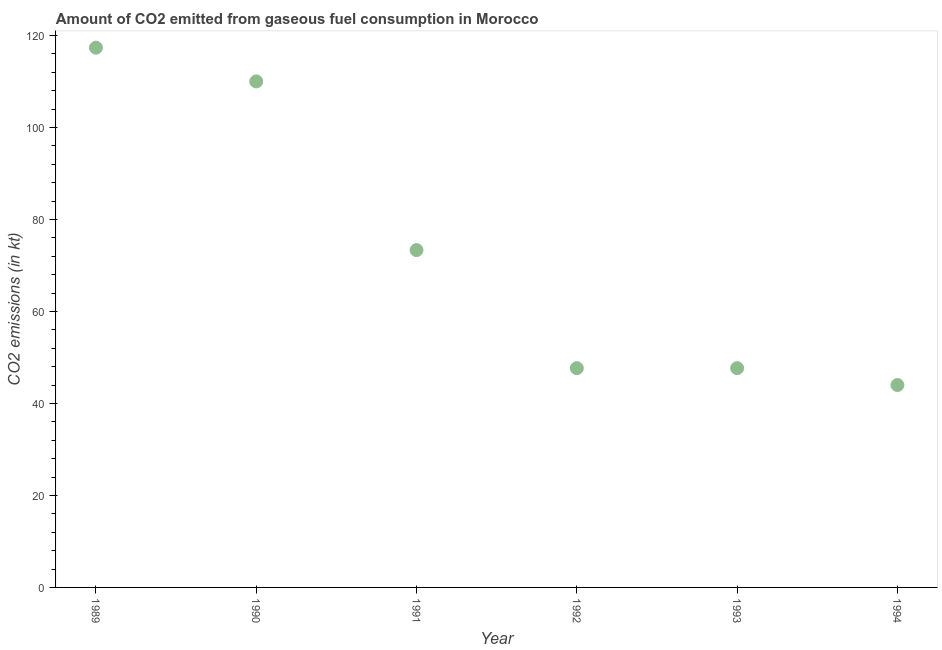What is the co2 emissions from gaseous fuel consumption in 1992?
Ensure brevity in your answer.  47.67. Across all years, what is the maximum co2 emissions from gaseous fuel consumption?
Provide a short and direct response. 117.34. Across all years, what is the minimum co2 emissions from gaseous fuel consumption?
Keep it short and to the point. 44. What is the sum of the co2 emissions from gaseous fuel consumption?
Your answer should be very brief. 440.04. What is the difference between the co2 emissions from gaseous fuel consumption in 1990 and 1994?
Provide a short and direct response. 66.01. What is the average co2 emissions from gaseous fuel consumption per year?
Your answer should be compact. 73.34. What is the median co2 emissions from gaseous fuel consumption?
Make the answer very short. 60.51. In how many years, is the co2 emissions from gaseous fuel consumption greater than 80 kt?
Your answer should be very brief. 2. What is the ratio of the co2 emissions from gaseous fuel consumption in 1989 to that in 1993?
Offer a very short reply. 2.46. What is the difference between the highest and the second highest co2 emissions from gaseous fuel consumption?
Make the answer very short. 7.33. Is the sum of the co2 emissions from gaseous fuel consumption in 1990 and 1994 greater than the maximum co2 emissions from gaseous fuel consumption across all years?
Provide a short and direct response. Yes. What is the difference between the highest and the lowest co2 emissions from gaseous fuel consumption?
Your response must be concise. 73.34. In how many years, is the co2 emissions from gaseous fuel consumption greater than the average co2 emissions from gaseous fuel consumption taken over all years?
Offer a very short reply. 3. Does the co2 emissions from gaseous fuel consumption monotonically increase over the years?
Provide a succinct answer. No. How many dotlines are there?
Offer a very short reply. 1. How many years are there in the graph?
Provide a short and direct response. 6. What is the difference between two consecutive major ticks on the Y-axis?
Your response must be concise. 20. What is the title of the graph?
Keep it short and to the point. Amount of CO2 emitted from gaseous fuel consumption in Morocco. What is the label or title of the X-axis?
Offer a very short reply. Year. What is the label or title of the Y-axis?
Provide a succinct answer. CO2 emissions (in kt). What is the CO2 emissions (in kt) in 1989?
Your answer should be compact. 117.34. What is the CO2 emissions (in kt) in 1990?
Your response must be concise. 110.01. What is the CO2 emissions (in kt) in 1991?
Offer a terse response. 73.34. What is the CO2 emissions (in kt) in 1992?
Provide a succinct answer. 47.67. What is the CO2 emissions (in kt) in 1993?
Your answer should be very brief. 47.67. What is the CO2 emissions (in kt) in 1994?
Ensure brevity in your answer.  44. What is the difference between the CO2 emissions (in kt) in 1989 and 1990?
Provide a succinct answer. 7.33. What is the difference between the CO2 emissions (in kt) in 1989 and 1991?
Your answer should be compact. 44. What is the difference between the CO2 emissions (in kt) in 1989 and 1992?
Offer a very short reply. 69.67. What is the difference between the CO2 emissions (in kt) in 1989 and 1993?
Your answer should be very brief. 69.67. What is the difference between the CO2 emissions (in kt) in 1989 and 1994?
Provide a short and direct response. 73.34. What is the difference between the CO2 emissions (in kt) in 1990 and 1991?
Ensure brevity in your answer.  36.67. What is the difference between the CO2 emissions (in kt) in 1990 and 1992?
Provide a short and direct response. 62.34. What is the difference between the CO2 emissions (in kt) in 1990 and 1993?
Offer a very short reply. 62.34. What is the difference between the CO2 emissions (in kt) in 1990 and 1994?
Make the answer very short. 66.01. What is the difference between the CO2 emissions (in kt) in 1991 and 1992?
Offer a terse response. 25.67. What is the difference between the CO2 emissions (in kt) in 1991 and 1993?
Make the answer very short. 25.67. What is the difference between the CO2 emissions (in kt) in 1991 and 1994?
Your response must be concise. 29.34. What is the difference between the CO2 emissions (in kt) in 1992 and 1993?
Your response must be concise. 0. What is the difference between the CO2 emissions (in kt) in 1992 and 1994?
Give a very brief answer. 3.67. What is the difference between the CO2 emissions (in kt) in 1993 and 1994?
Provide a short and direct response. 3.67. What is the ratio of the CO2 emissions (in kt) in 1989 to that in 1990?
Your answer should be compact. 1.07. What is the ratio of the CO2 emissions (in kt) in 1989 to that in 1991?
Ensure brevity in your answer.  1.6. What is the ratio of the CO2 emissions (in kt) in 1989 to that in 1992?
Give a very brief answer. 2.46. What is the ratio of the CO2 emissions (in kt) in 1989 to that in 1993?
Make the answer very short. 2.46. What is the ratio of the CO2 emissions (in kt) in 1989 to that in 1994?
Your response must be concise. 2.67. What is the ratio of the CO2 emissions (in kt) in 1990 to that in 1991?
Your response must be concise. 1.5. What is the ratio of the CO2 emissions (in kt) in 1990 to that in 1992?
Your answer should be compact. 2.31. What is the ratio of the CO2 emissions (in kt) in 1990 to that in 1993?
Give a very brief answer. 2.31. What is the ratio of the CO2 emissions (in kt) in 1990 to that in 1994?
Keep it short and to the point. 2.5. What is the ratio of the CO2 emissions (in kt) in 1991 to that in 1992?
Give a very brief answer. 1.54. What is the ratio of the CO2 emissions (in kt) in 1991 to that in 1993?
Your answer should be compact. 1.54. What is the ratio of the CO2 emissions (in kt) in 1991 to that in 1994?
Give a very brief answer. 1.67. What is the ratio of the CO2 emissions (in kt) in 1992 to that in 1994?
Give a very brief answer. 1.08. What is the ratio of the CO2 emissions (in kt) in 1993 to that in 1994?
Ensure brevity in your answer.  1.08. 